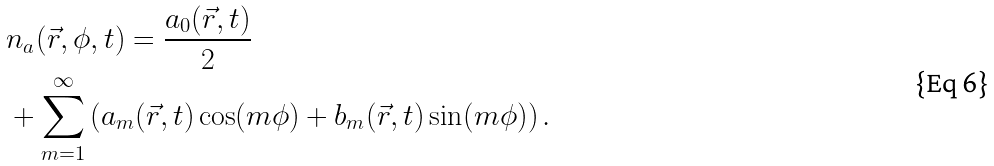<formula> <loc_0><loc_0><loc_500><loc_500>& n _ { a } ( \vec { r } , \phi , t ) = \frac { a _ { 0 } ( \vec { r } , t ) } { 2 } \\ & + \sum _ { m = 1 } ^ { \infty } \left ( a _ { m } ( \vec { r } , t ) \cos ( m \phi ) + b _ { m } ( \vec { r } , t ) \sin ( m \phi ) \right ) . \</formula> 